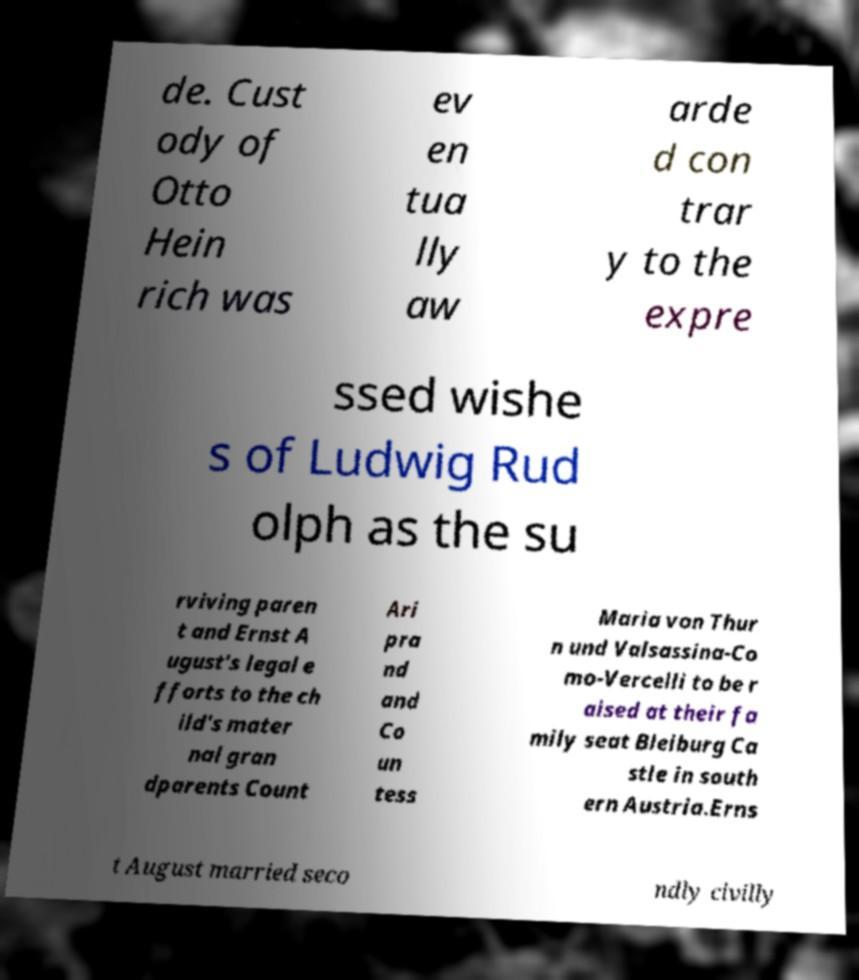Please identify and transcribe the text found in this image. de. Cust ody of Otto Hein rich was ev en tua lly aw arde d con trar y to the expre ssed wishe s of Ludwig Rud olph as the su rviving paren t and Ernst A ugust's legal e fforts to the ch ild's mater nal gran dparents Count Ari pra nd and Co un tess Maria von Thur n und Valsassina-Co mo-Vercelli to be r aised at their fa mily seat Bleiburg Ca stle in south ern Austria.Erns t August married seco ndly civilly 